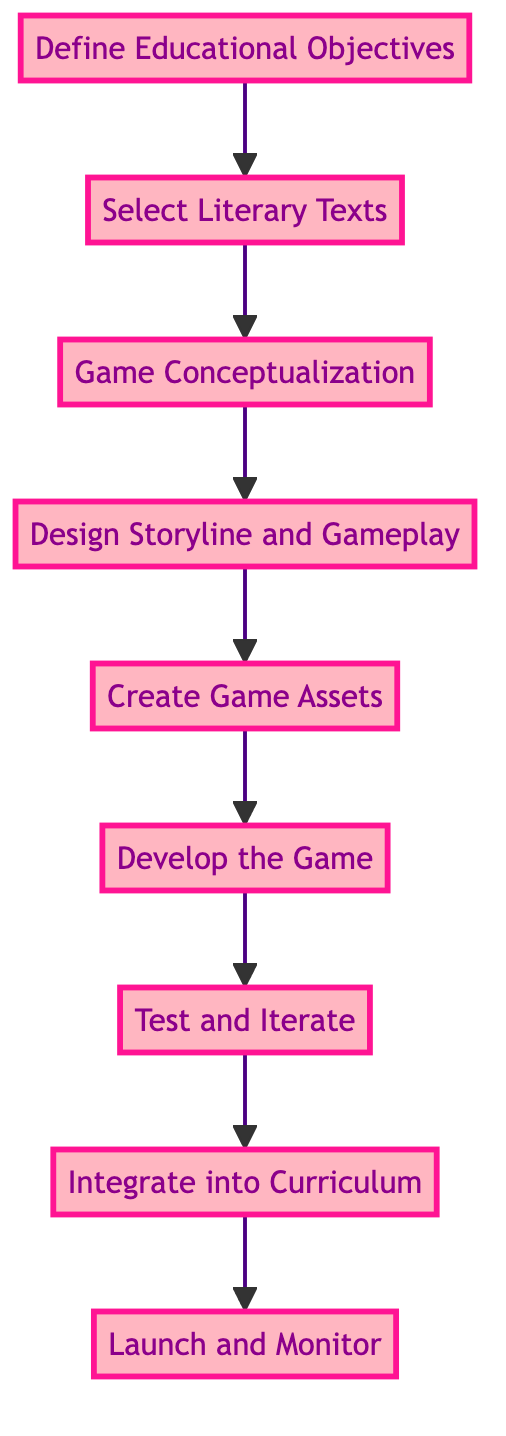What is the first step in creating an interactive educational game? The diagram starts with the node labeled "Define Educational Objectives," which indicates that this is the initial step in the process.
Answer: Define Educational Objectives How many total steps are included in the diagram? By counting each node listed in the flow chart (from "Define Educational Objectives" to "Launch and Monitor"), there are a total of 9 distinct steps.
Answer: 9 Which step follows "Select Literary Texts"? The directed flow of the diagram shows that after "Select Literary Texts," the next step is "Game Conceptualization."
Answer: Game Conceptualization What is the last step in the flow chart? The last node in the flow chart is labeled "Launch and Monitor," indicating that this is the final step in the process of creating the game.
Answer: Launch and Monitor What are the two steps that directly precede "Test and Iterate"? Referring to the diagram, "Develop the Game" comes just before "Test and Iterate," and "Create Game Assets" is the step before "Develop the Game." Therefore, the steps that precede "Test and Iterate" are "Develop the Game" and "Create Game Assets."
Answer: Develop the Game, Create Game Assets What is the relationship between "Design Storyline and Gameplay" and "Create Game Assets"? The diagram shows a direct workflow from "Design Storyline and Gameplay" to "Create Game Assets," indicating that you first design the storyline before creating the necessary assets.
Answer: The first step in the process is followed by the next How is “Integrate into Curriculum” related to the previous steps? In the diagram, "Integrate into Curriculum" is the step that comes after "Test and Iterate," indicating it is a crucial step to finalize how the created game will fit into the educational framework.
Answer: It's the step after testing the game Which step introduces game ideas that align with educational objectives? The flow chart specifically identifies "Game Conceptualization" as the step where brainstorming of game ideas happens that are aligned with the educational objectives established at the beginning.
Answer: Game Conceptualization What does the step “Develop the Game” involve? According to the description in the diagram, “Develop the Game” involves building the game using software tools and incorporating mini-games related to text comprehension, essential for learning through gameplay.
Answer: Building the game using development software What action follows after “Launch and Monitor”? The flowchart indicates that “Launch and Monitor” is the final step, meaning there are no further actions defined in the diagram thereafter.
Answer: No further actions defined 